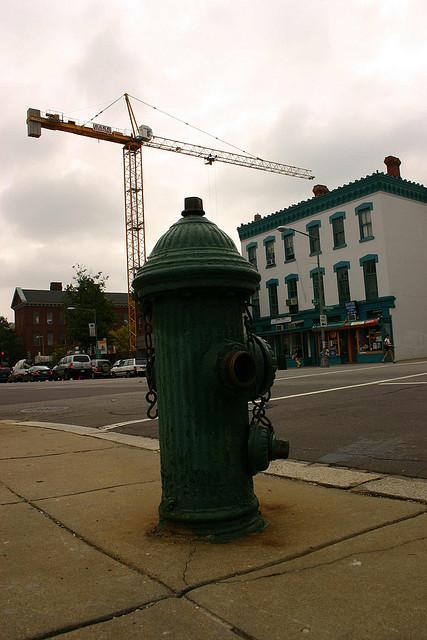Is there a fire?
Give a very brief answer. No. Where is the crane?
Keep it brief. Background. Is there a fire hydrant on the side of a road?
Write a very short answer. Yes. 